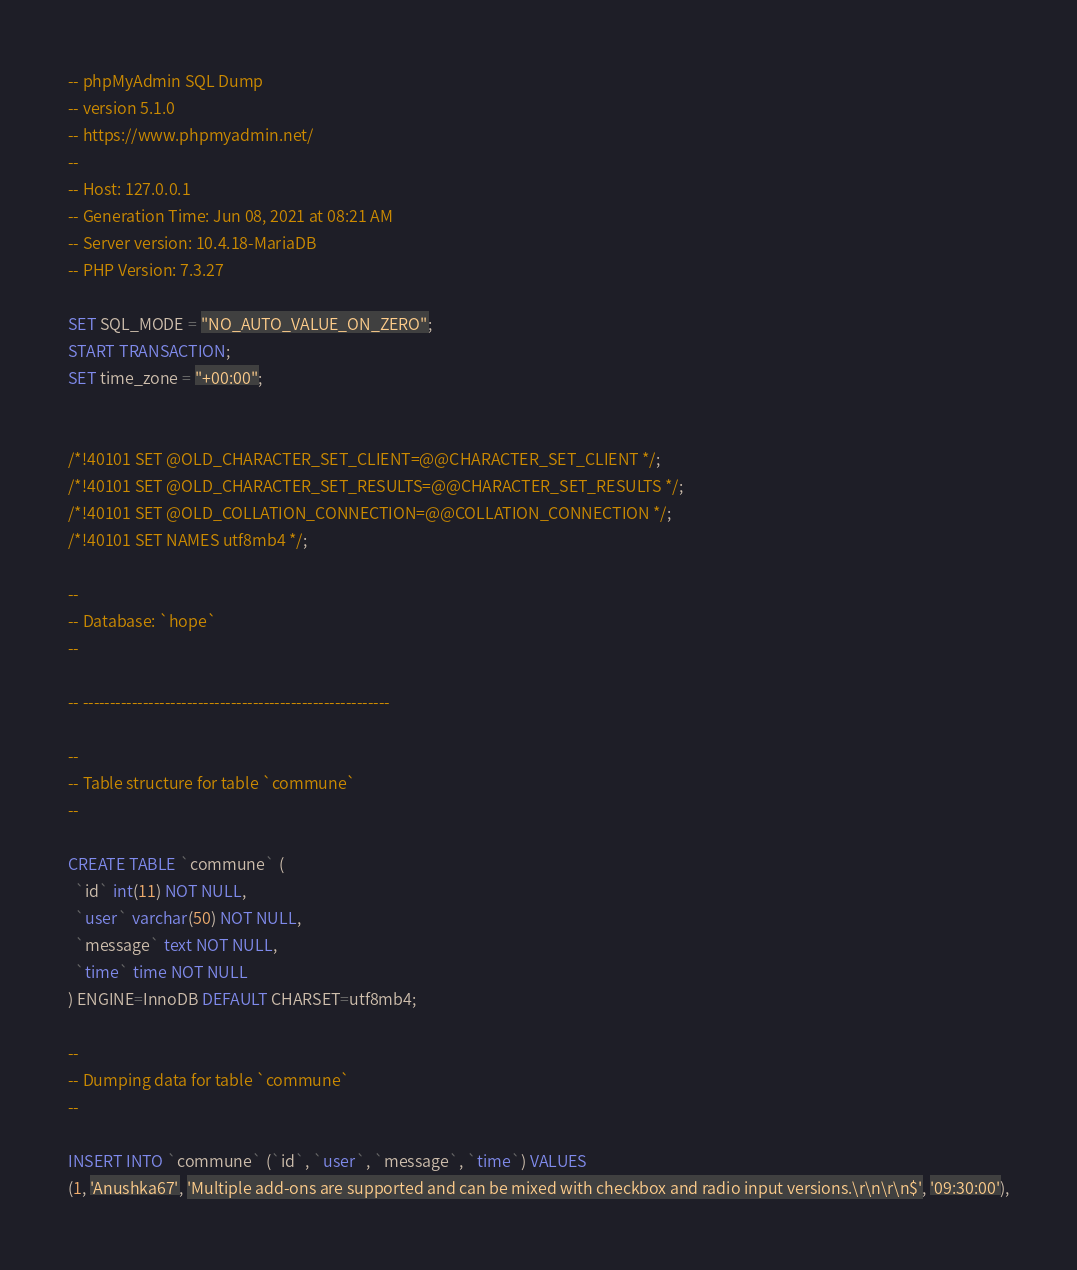<code> <loc_0><loc_0><loc_500><loc_500><_SQL_>-- phpMyAdmin SQL Dump
-- version 5.1.0
-- https://www.phpmyadmin.net/
--
-- Host: 127.0.0.1
-- Generation Time: Jun 08, 2021 at 08:21 AM
-- Server version: 10.4.18-MariaDB
-- PHP Version: 7.3.27

SET SQL_MODE = "NO_AUTO_VALUE_ON_ZERO";
START TRANSACTION;
SET time_zone = "+00:00";


/*!40101 SET @OLD_CHARACTER_SET_CLIENT=@@CHARACTER_SET_CLIENT */;
/*!40101 SET @OLD_CHARACTER_SET_RESULTS=@@CHARACTER_SET_RESULTS */;
/*!40101 SET @OLD_COLLATION_CONNECTION=@@COLLATION_CONNECTION */;
/*!40101 SET NAMES utf8mb4 */;

--
-- Database: `hope`
--

-- --------------------------------------------------------

--
-- Table structure for table `commune`
--

CREATE TABLE `commune` (
  `id` int(11) NOT NULL,
  `user` varchar(50) NOT NULL,
  `message` text NOT NULL,
  `time` time NOT NULL
) ENGINE=InnoDB DEFAULT CHARSET=utf8mb4;

--
-- Dumping data for table `commune`
--

INSERT INTO `commune` (`id`, `user`, `message`, `time`) VALUES
(1, 'Anushka67', 'Multiple add-ons are supported and can be mixed with checkbox and radio input versions.\r\n\r\n$', '09:30:00'),</code> 